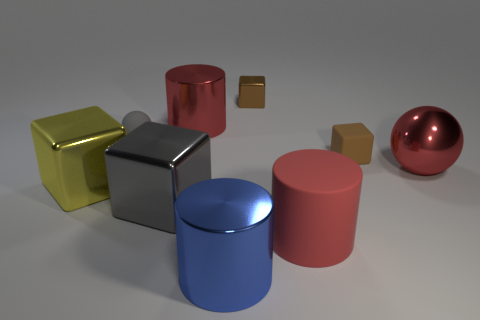There is another large cylinder that is made of the same material as the blue cylinder; what color is it?
Give a very brief answer. Red. Do the blue thing and the gray thing that is on the left side of the large gray block have the same shape?
Keep it short and to the point. No. Are there any rubber cubes in front of the blue metallic thing?
Offer a very short reply. No. There is a small object that is the same color as the small metal cube; what material is it?
Your response must be concise. Rubber. Do the yellow metallic block and the red thing that is to the left of the blue shiny cylinder have the same size?
Ensure brevity in your answer.  Yes. Are there any matte objects of the same color as the small metallic object?
Provide a succinct answer. Yes. Are there any gray matte objects that have the same shape as the red rubber object?
Your answer should be compact. No. What is the shape of the rubber thing that is to the right of the big blue object and behind the big gray metallic thing?
Make the answer very short. Cube. What number of small brown things have the same material as the yellow cube?
Your answer should be compact. 1. Is the number of big matte things that are on the left side of the blue thing less than the number of brown rubber objects?
Your response must be concise. Yes. 